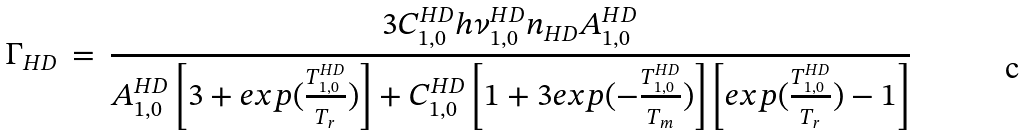Convert formula to latex. <formula><loc_0><loc_0><loc_500><loc_500>\Gamma _ { H D } \, = \, \frac { 3 C _ { 1 , 0 } ^ { H D } h \nu _ { 1 , 0 } ^ { H D } n _ { H D } A _ { 1 , 0 } ^ { H D } } { A _ { 1 , 0 } ^ { H D } \left [ 3 + e x p ( \frac { T _ { 1 , 0 } ^ { H D } } { T _ { r } } ) \right ] + C _ { 1 , 0 } ^ { H D } \left [ 1 + 3 e x p ( - \frac { T _ { 1 , 0 } ^ { H D } } { T _ { m } } ) \right ] \left [ e x p ( \frac { T _ { 1 , 0 } ^ { H D } } { T _ { r } } ) - 1 \right ] }</formula> 